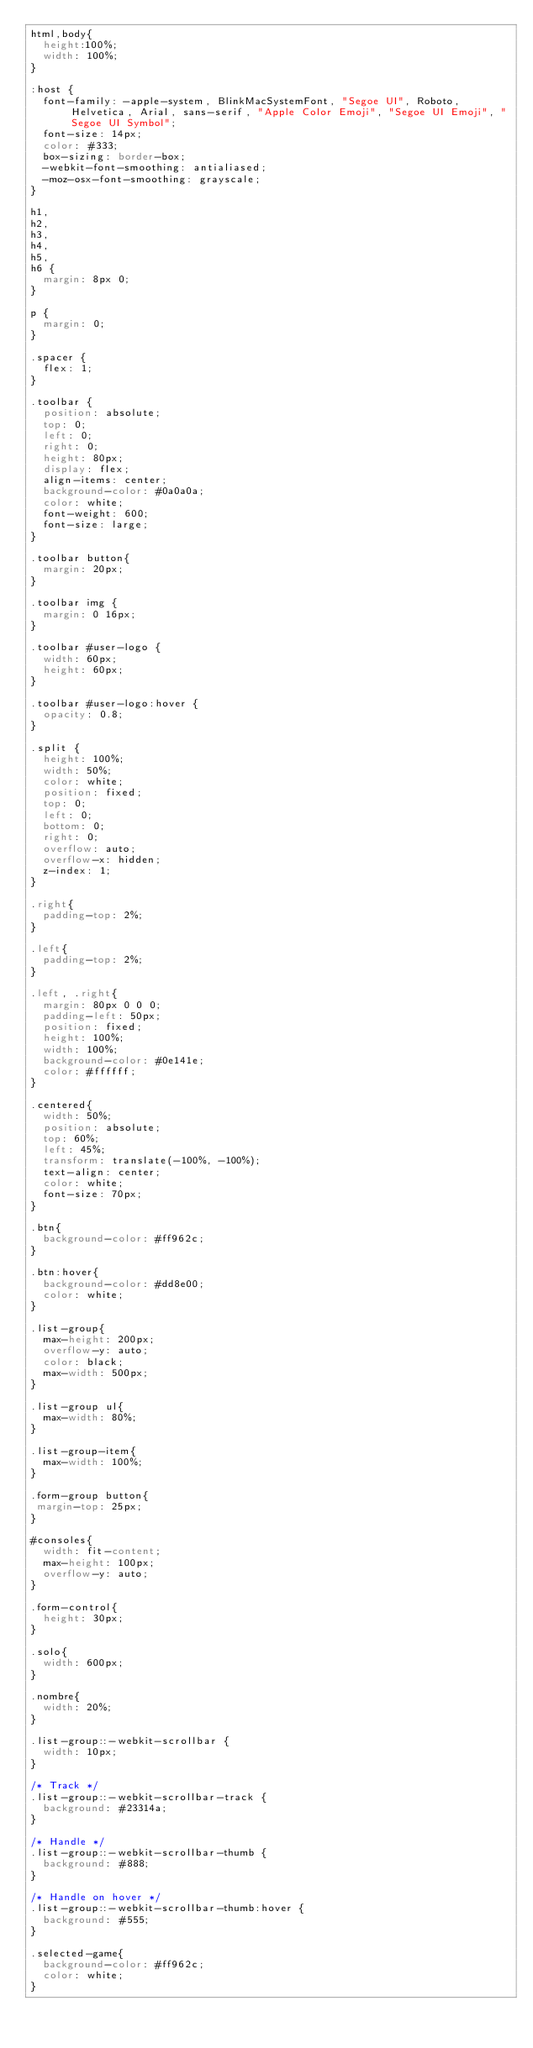Convert code to text. <code><loc_0><loc_0><loc_500><loc_500><_CSS_>html,body{
  height:100%;
  width: 100%;
}

:host {
  font-family: -apple-system, BlinkMacSystemFont, "Segoe UI", Roboto, Helvetica, Arial, sans-serif, "Apple Color Emoji", "Segoe UI Emoji", "Segoe UI Symbol";
  font-size: 14px;
  color: #333;
  box-sizing: border-box;
  -webkit-font-smoothing: antialiased;
  -moz-osx-font-smoothing: grayscale;
}

h1,
h2,
h3,
h4,
h5,
h6 {
  margin: 8px 0;
}

p {
  margin: 0;
}

.spacer {
  flex: 1;
}

.toolbar {
  position: absolute;
  top: 0;
  left: 0;
  right: 0;
  height: 80px;
  display: flex;
  align-items: center;
  background-color: #0a0a0a;
  color: white;
  font-weight: 600;
  font-size: large;
}

.toolbar button{
  margin: 20px;
}

.toolbar img {
  margin: 0 16px;
}

.toolbar #user-logo {
  width: 60px;
  height: 60px;
}

.toolbar #user-logo:hover {
  opacity: 0.8;
}

.split {
  height: 100%;
  width: 50%;
  color: white;
  position: fixed;
  top: 0;
  left: 0;
  bottom: 0;
  right: 0;
  overflow: auto;
  overflow-x: hidden;
  z-index: 1;
}

.right{
  padding-top: 2%;
}

.left{
  padding-top: 2%;
}

.left, .right{
  margin: 80px 0 0 0;
  padding-left: 50px;
  position: fixed;
  height: 100%;
  width: 100%;
  background-color: #0e141e;
  color: #ffffff;
}

.centered{
  width: 50%;
  position: absolute;
  top: 60%;
  left: 45%;
  transform: translate(-100%, -100%);
  text-align: center;
  color: white;
  font-size: 70px;
}

.btn{
  background-color: #ff962c;
}

.btn:hover{
  background-color: #dd8e00;
  color: white;
}

.list-group{
  max-height: 200px;
  overflow-y: auto;
  color: black;
  max-width: 500px;
}

.list-group ul{
  max-width: 80%;
}

.list-group-item{
  max-width: 100%;
}

.form-group button{
 margin-top: 25px;
}

#consoles{
  width: fit-content;
  max-height: 100px;
  overflow-y: auto;
}

.form-control{
  height: 30px;
}

.solo{
  width: 600px;
}

.nombre{
  width: 20%;
}

.list-group::-webkit-scrollbar {
  width: 10px;
}

/* Track */
.list-group::-webkit-scrollbar-track {
  background: #23314a;
}

/* Handle */
.list-group::-webkit-scrollbar-thumb {
  background: #888;
}

/* Handle on hover */
.list-group::-webkit-scrollbar-thumb:hover {
  background: #555;
}

.selected-game{
  background-color: #ff962c;
  color: white;
}
</code> 